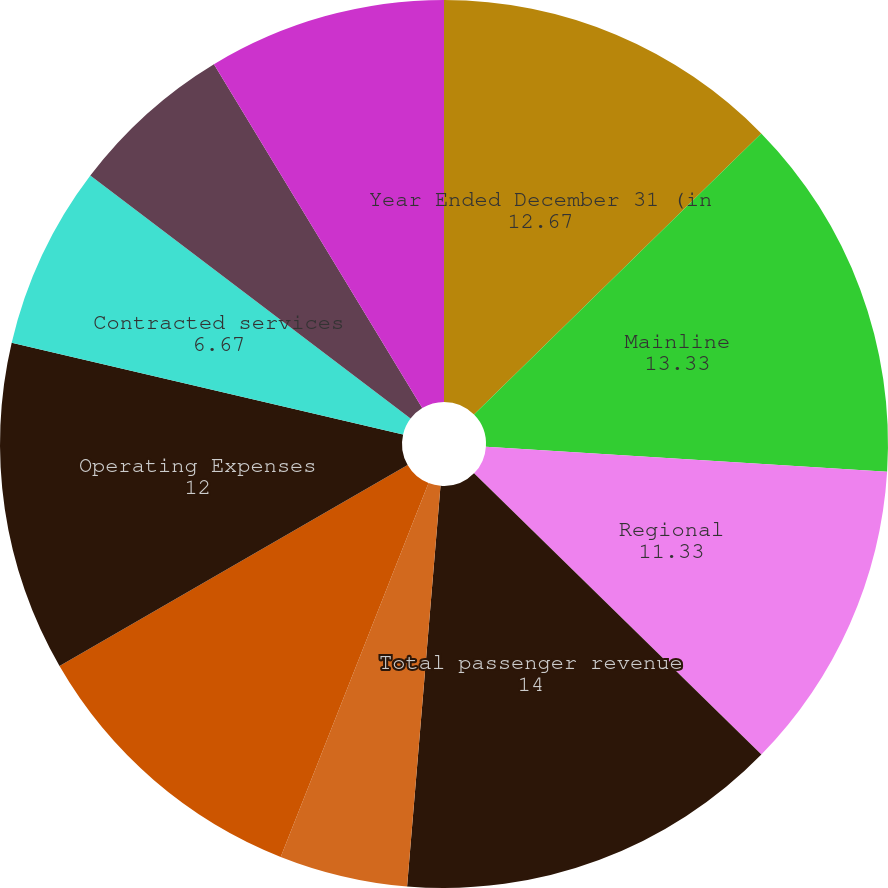Convert chart to OTSL. <chart><loc_0><loc_0><loc_500><loc_500><pie_chart><fcel>Year Ended December 31 (in<fcel>Mainline<fcel>Regional<fcel>Total passenger revenue<fcel>Freight and mail<fcel>Other-net Total Operating<fcel>Operating Expenses<fcel>Contracted services<fcel>Selling expenses<fcel>Depreciation and amortization<nl><fcel>12.67%<fcel>13.33%<fcel>11.33%<fcel>14.0%<fcel>4.67%<fcel>10.67%<fcel>12.0%<fcel>6.67%<fcel>6.0%<fcel>8.67%<nl></chart> 